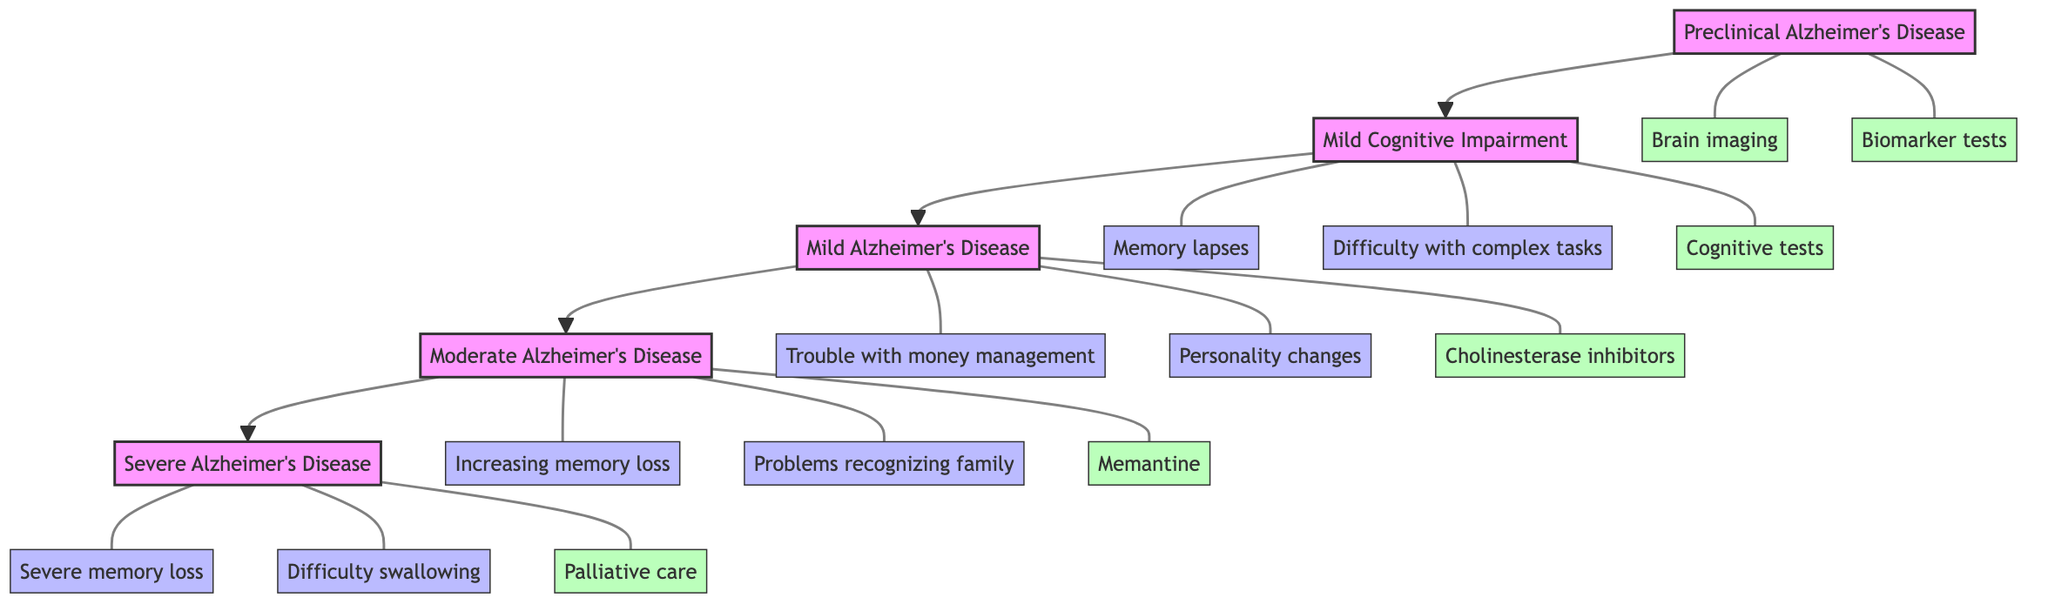What is the first stage of Alzheimer's Disease in this clinical pathway? The diagram shows the stages in a flowchart format, starting with "Preclinical Alzheimer's Disease" as the first stage at the top.
Answer: Preclinical Alzheimer's Disease How many total stages are represented in the diagram? The diagram lists five distinct stages from "Preclinical Alzheimer's Disease" to "Severe Alzheimer's Disease," confirming a total of five stages.
Answer: 5 Which stage includes "Memory lapses"? The symptom "Memory lapses" is listed under the "Mild Cognitive Impairment" stage, which is the second stage in the flowchart.
Answer: Mild Cognitive Impairment What kind of clinical activities are associated with "Severe Alzheimer's Disease"? The diagram associates "Palliative care," "Management of coexisting medical conditions," "24-hour supervision and care," and "Nutritional support" with the "Severe Alzheimer's Disease" stage.
Answer: Palliative care, Management of coexisting medical conditions, 24-hour supervision and care, Nutritional support Which stage has "Repeating questions" as a symptom? "Repeating questions" is mentioned under "Mild Alzheimer's Disease," which is the third stage according to the flowchart.
Answer: Mild Alzheimer's Disease What common feature can be found across all stages of Alzheimer's Disease in this pathway? Across all stages, there is a notable progression in the severity of symptoms and clinical activities, reflecting the deterioration of cognitive functions. Each stage is linked with specific symptoms and corresponding clinical activities that align with that severity level.
Answer: Progression in severity Which clinical activity is unique to the "Moderate Alzheimer's Disease" stage? "Memantine" is listed specifically as a clinical activity associated with "Moderate Alzheimer's Disease," distinguishing it from other stages.
Answer: Memantine What is the last listed symptom in the "Severe Alzheimer's Disease" stage? The last symptom listed under "Severe Alzheimer's Disease" is "Major personality changes," which is part of the description of this advanced stage.
Answer: Major personality changes 